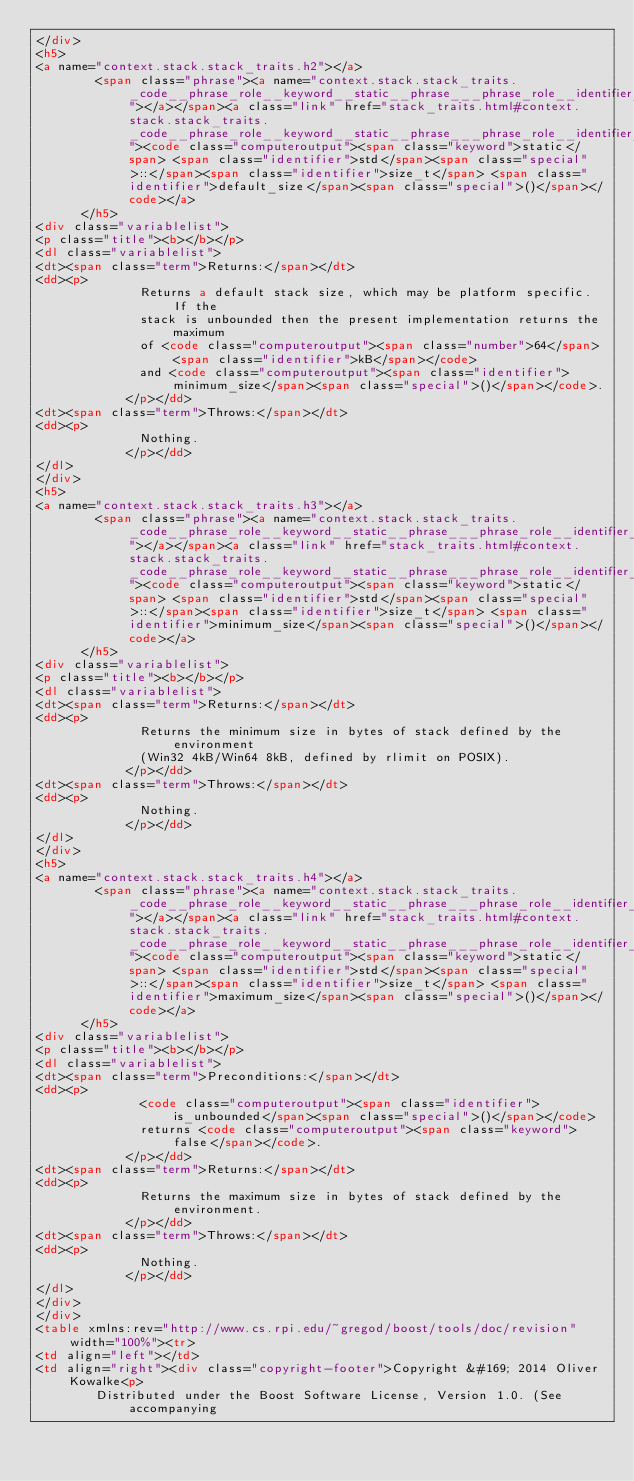Convert code to text. <code><loc_0><loc_0><loc_500><loc_500><_HTML_></div>
<h5>
<a name="context.stack.stack_traits.h2"></a>
        <span class="phrase"><a name="context.stack.stack_traits._code__phrase_role__keyword__static__phrase___phrase_role__identifier__std__phrase__phrase_role__special______phrase__phrase_role__identifier__size_t__phrase___phrase_role__identifier__default_size__phrase__phrase_role__special______phrase___code_"></a></span><a class="link" href="stack_traits.html#context.stack.stack_traits._code__phrase_role__keyword__static__phrase___phrase_role__identifier__std__phrase__phrase_role__special______phrase__phrase_role__identifier__size_t__phrase___phrase_role__identifier__default_size__phrase__phrase_role__special______phrase___code_"><code class="computeroutput"><span class="keyword">static</span> <span class="identifier">std</span><span class="special">::</span><span class="identifier">size_t</span> <span class="identifier">default_size</span><span class="special">()</span></code></a>
      </h5>
<div class="variablelist">
<p class="title"><b></b></p>
<dl class="variablelist">
<dt><span class="term">Returns:</span></dt>
<dd><p>
              Returns a default stack size, which may be platform specific. If the
              stack is unbounded then the present implementation returns the maximum
              of <code class="computeroutput"><span class="number">64</span> <span class="identifier">kB</span></code>
              and <code class="computeroutput"><span class="identifier">minimum_size</span><span class="special">()</span></code>.
            </p></dd>
<dt><span class="term">Throws:</span></dt>
<dd><p>
              Nothing.
            </p></dd>
</dl>
</div>
<h5>
<a name="context.stack.stack_traits.h3"></a>
        <span class="phrase"><a name="context.stack.stack_traits._code__phrase_role__keyword__static__phrase___phrase_role__identifier__std__phrase__phrase_role__special______phrase__phrase_role__identifier__size_t__phrase___phrase_role__identifier__minimum_size__phrase__phrase_role__special______phrase___code_"></a></span><a class="link" href="stack_traits.html#context.stack.stack_traits._code__phrase_role__keyword__static__phrase___phrase_role__identifier__std__phrase__phrase_role__special______phrase__phrase_role__identifier__size_t__phrase___phrase_role__identifier__minimum_size__phrase__phrase_role__special______phrase___code_"><code class="computeroutput"><span class="keyword">static</span> <span class="identifier">std</span><span class="special">::</span><span class="identifier">size_t</span> <span class="identifier">minimum_size</span><span class="special">()</span></code></a>
      </h5>
<div class="variablelist">
<p class="title"><b></b></p>
<dl class="variablelist">
<dt><span class="term">Returns:</span></dt>
<dd><p>
              Returns the minimum size in bytes of stack defined by the environment
              (Win32 4kB/Win64 8kB, defined by rlimit on POSIX).
            </p></dd>
<dt><span class="term">Throws:</span></dt>
<dd><p>
              Nothing.
            </p></dd>
</dl>
</div>
<h5>
<a name="context.stack.stack_traits.h4"></a>
        <span class="phrase"><a name="context.stack.stack_traits._code__phrase_role__keyword__static__phrase___phrase_role__identifier__std__phrase__phrase_role__special______phrase__phrase_role__identifier__size_t__phrase___phrase_role__identifier__maximum_size__phrase__phrase_role__special______phrase___code_"></a></span><a class="link" href="stack_traits.html#context.stack.stack_traits._code__phrase_role__keyword__static__phrase___phrase_role__identifier__std__phrase__phrase_role__special______phrase__phrase_role__identifier__size_t__phrase___phrase_role__identifier__maximum_size__phrase__phrase_role__special______phrase___code_"><code class="computeroutput"><span class="keyword">static</span> <span class="identifier">std</span><span class="special">::</span><span class="identifier">size_t</span> <span class="identifier">maximum_size</span><span class="special">()</span></code></a>
      </h5>
<div class="variablelist">
<p class="title"><b></b></p>
<dl class="variablelist">
<dt><span class="term">Preconditions:</span></dt>
<dd><p>
              <code class="computeroutput"><span class="identifier">is_unbounded</span><span class="special">()</span></code>
              returns <code class="computeroutput"><span class="keyword">false</span></code>.
            </p></dd>
<dt><span class="term">Returns:</span></dt>
<dd><p>
              Returns the maximum size in bytes of stack defined by the environment.
            </p></dd>
<dt><span class="term">Throws:</span></dt>
<dd><p>
              Nothing.
            </p></dd>
</dl>
</div>
</div>
<table xmlns:rev="http://www.cs.rpi.edu/~gregod/boost/tools/doc/revision" width="100%"><tr>
<td align="left"></td>
<td align="right"><div class="copyright-footer">Copyright &#169; 2014 Oliver Kowalke<p>
        Distributed under the Boost Software License, Version 1.0. (See accompanying</code> 